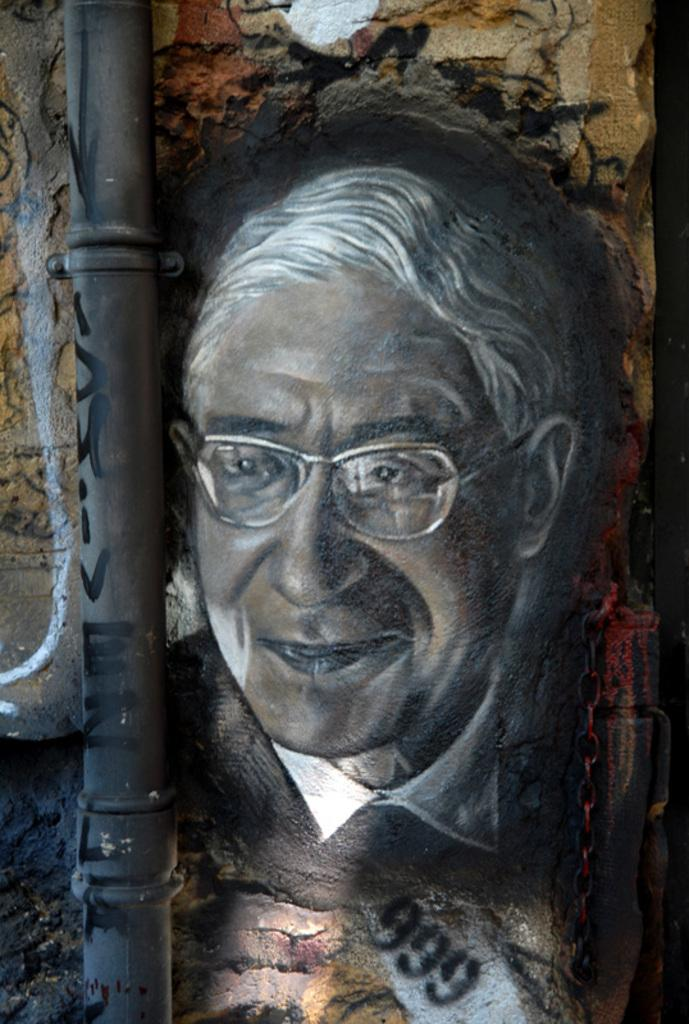What object can be seen in the image that is used for transporting fluids? There is a pipe in the image that is used for transporting fluids. What is depicted on the painting in the image? The painting in the image is of a man. What can be observed about the man's appearance in the painting? The man in the painting is wearing spectacles. What expression does the man have in the painting? The man in the painting is smiling. Where is the painting located in the image? The painting is on a wall in the image. What type of silver rake is being used by the man in the painting? There is no silver rake present in the image, and the man in the painting is not using any tools or objects. 